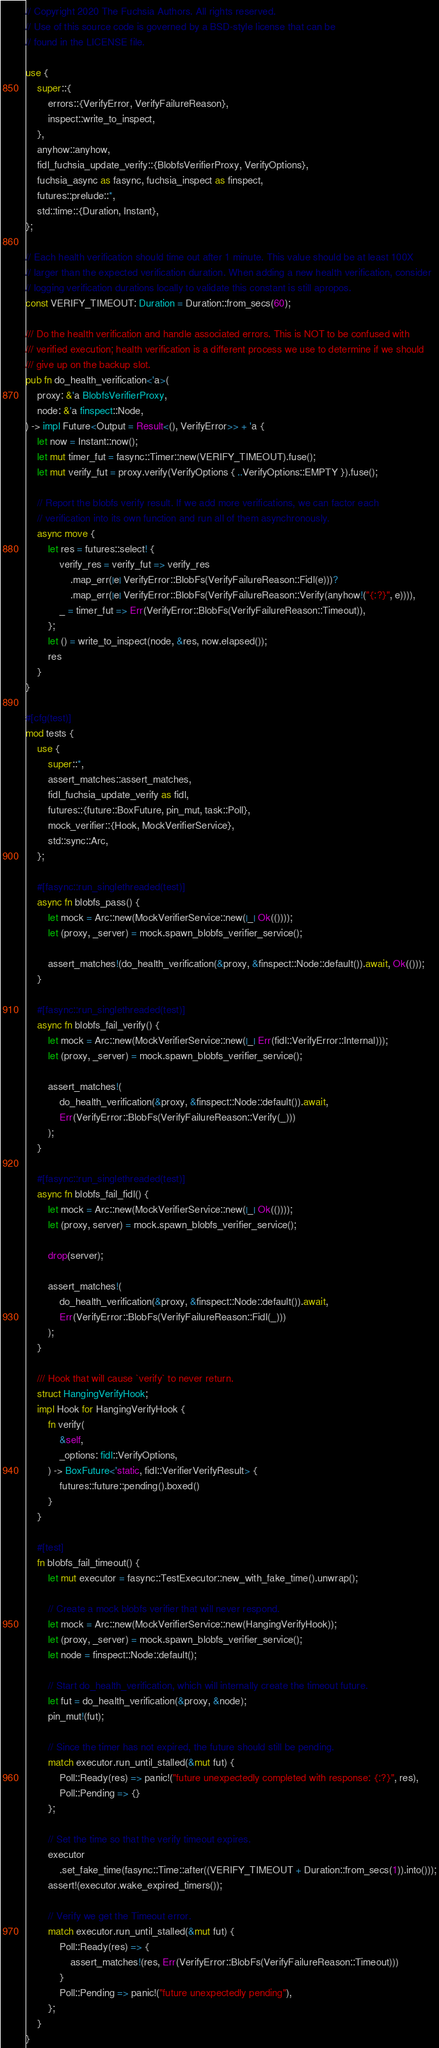<code> <loc_0><loc_0><loc_500><loc_500><_Rust_>// Copyright 2020 The Fuchsia Authors. All rights reserved.
// Use of this source code is governed by a BSD-style license that can be
// found in the LICENSE file.

use {
    super::{
        errors::{VerifyError, VerifyFailureReason},
        inspect::write_to_inspect,
    },
    anyhow::anyhow,
    fidl_fuchsia_update_verify::{BlobfsVerifierProxy, VerifyOptions},
    fuchsia_async as fasync, fuchsia_inspect as finspect,
    futures::prelude::*,
    std::time::{Duration, Instant},
};

// Each health verification should time out after 1 minute. This value should be at least 100X
// larger than the expected verification duration. When adding a new health verification, consider
// logging verification durations locally to validate this constant is still apropos.
const VERIFY_TIMEOUT: Duration = Duration::from_secs(60);

/// Do the health verification and handle associated errors. This is NOT to be confused with
/// verified execution; health verification is a different process we use to determine if we should
/// give up on the backup slot.
pub fn do_health_verification<'a>(
    proxy: &'a BlobfsVerifierProxy,
    node: &'a finspect::Node,
) -> impl Future<Output = Result<(), VerifyError>> + 'a {
    let now = Instant::now();
    let mut timer_fut = fasync::Timer::new(VERIFY_TIMEOUT).fuse();
    let mut verify_fut = proxy.verify(VerifyOptions { ..VerifyOptions::EMPTY }).fuse();

    // Report the blobfs verify result. If we add more verifications, we can factor each
    // verification into its own function and run all of them asynchronously.
    async move {
        let res = futures::select! {
            verify_res = verify_fut => verify_res
                .map_err(|e| VerifyError::BlobFs(VerifyFailureReason::Fidl(e)))?
                .map_err(|e| VerifyError::BlobFs(VerifyFailureReason::Verify(anyhow!("{:?}", e)))),
            _ = timer_fut => Err(VerifyError::BlobFs(VerifyFailureReason::Timeout)),
        };
        let () = write_to_inspect(node, &res, now.elapsed());
        res
    }
}

#[cfg(test)]
mod tests {
    use {
        super::*,
        assert_matches::assert_matches,
        fidl_fuchsia_update_verify as fidl,
        futures::{future::BoxFuture, pin_mut, task::Poll},
        mock_verifier::{Hook, MockVerifierService},
        std::sync::Arc,
    };

    #[fasync::run_singlethreaded(test)]
    async fn blobfs_pass() {
        let mock = Arc::new(MockVerifierService::new(|_| Ok(())));
        let (proxy, _server) = mock.spawn_blobfs_verifier_service();

        assert_matches!(do_health_verification(&proxy, &finspect::Node::default()).await, Ok(()));
    }

    #[fasync::run_singlethreaded(test)]
    async fn blobfs_fail_verify() {
        let mock = Arc::new(MockVerifierService::new(|_| Err(fidl::VerifyError::Internal)));
        let (proxy, _server) = mock.spawn_blobfs_verifier_service();

        assert_matches!(
            do_health_verification(&proxy, &finspect::Node::default()).await,
            Err(VerifyError::BlobFs(VerifyFailureReason::Verify(_)))
        );
    }

    #[fasync::run_singlethreaded(test)]
    async fn blobfs_fail_fidl() {
        let mock = Arc::new(MockVerifierService::new(|_| Ok(())));
        let (proxy, server) = mock.spawn_blobfs_verifier_service();

        drop(server);

        assert_matches!(
            do_health_verification(&proxy, &finspect::Node::default()).await,
            Err(VerifyError::BlobFs(VerifyFailureReason::Fidl(_)))
        );
    }

    /// Hook that will cause `verify` to never return.
    struct HangingVerifyHook;
    impl Hook for HangingVerifyHook {
        fn verify(
            &self,
            _options: fidl::VerifyOptions,
        ) -> BoxFuture<'static, fidl::VerifierVerifyResult> {
            futures::future::pending().boxed()
        }
    }

    #[test]
    fn blobfs_fail_timeout() {
        let mut executor = fasync::TestExecutor::new_with_fake_time().unwrap();

        // Create a mock blobfs verifier that will never respond.
        let mock = Arc::new(MockVerifierService::new(HangingVerifyHook));
        let (proxy, _server) = mock.spawn_blobfs_verifier_service();
        let node = finspect::Node::default();

        // Start do_health_verification, which will internally create the timeout future.
        let fut = do_health_verification(&proxy, &node);
        pin_mut!(fut);

        // Since the timer has not expired, the future should still be pending.
        match executor.run_until_stalled(&mut fut) {
            Poll::Ready(res) => panic!("future unexpectedly completed with response: {:?}", res),
            Poll::Pending => {}
        };

        // Set the time so that the verify timeout expires.
        executor
            .set_fake_time(fasync::Time::after((VERIFY_TIMEOUT + Duration::from_secs(1)).into()));
        assert!(executor.wake_expired_timers());

        // Verify we get the Timeout error.
        match executor.run_until_stalled(&mut fut) {
            Poll::Ready(res) => {
                assert_matches!(res, Err(VerifyError::BlobFs(VerifyFailureReason::Timeout)))
            }
            Poll::Pending => panic!("future unexpectedly pending"),
        };
    }
}
</code> 